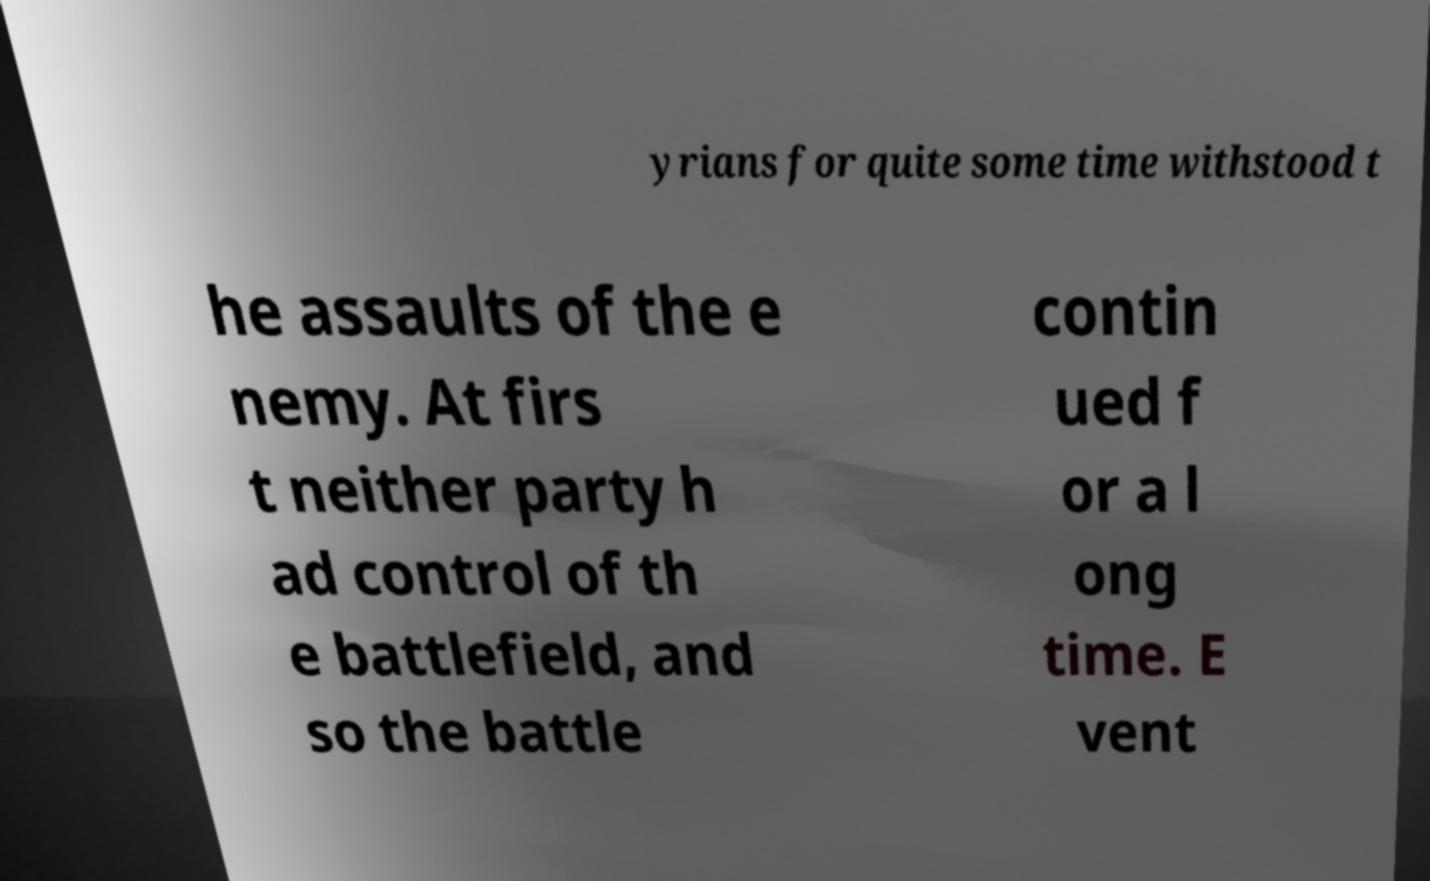What messages or text are displayed in this image? I need them in a readable, typed format. yrians for quite some time withstood t he assaults of the e nemy. At firs t neither party h ad control of th e battlefield, and so the battle contin ued f or a l ong time. E vent 